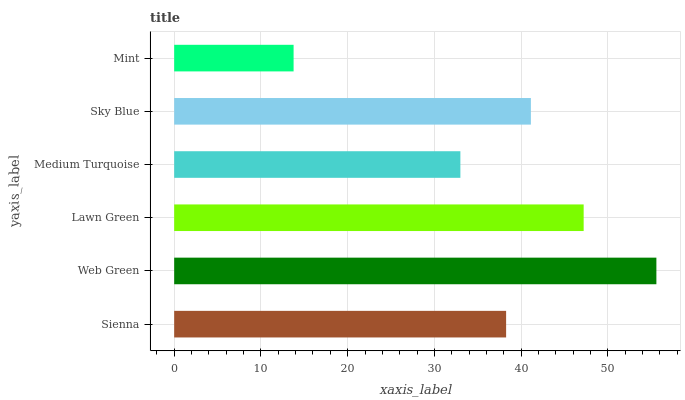Is Mint the minimum?
Answer yes or no. Yes. Is Web Green the maximum?
Answer yes or no. Yes. Is Lawn Green the minimum?
Answer yes or no. No. Is Lawn Green the maximum?
Answer yes or no. No. Is Web Green greater than Lawn Green?
Answer yes or no. Yes. Is Lawn Green less than Web Green?
Answer yes or no. Yes. Is Lawn Green greater than Web Green?
Answer yes or no. No. Is Web Green less than Lawn Green?
Answer yes or no. No. Is Sky Blue the high median?
Answer yes or no. Yes. Is Sienna the low median?
Answer yes or no. Yes. Is Web Green the high median?
Answer yes or no. No. Is Web Green the low median?
Answer yes or no. No. 